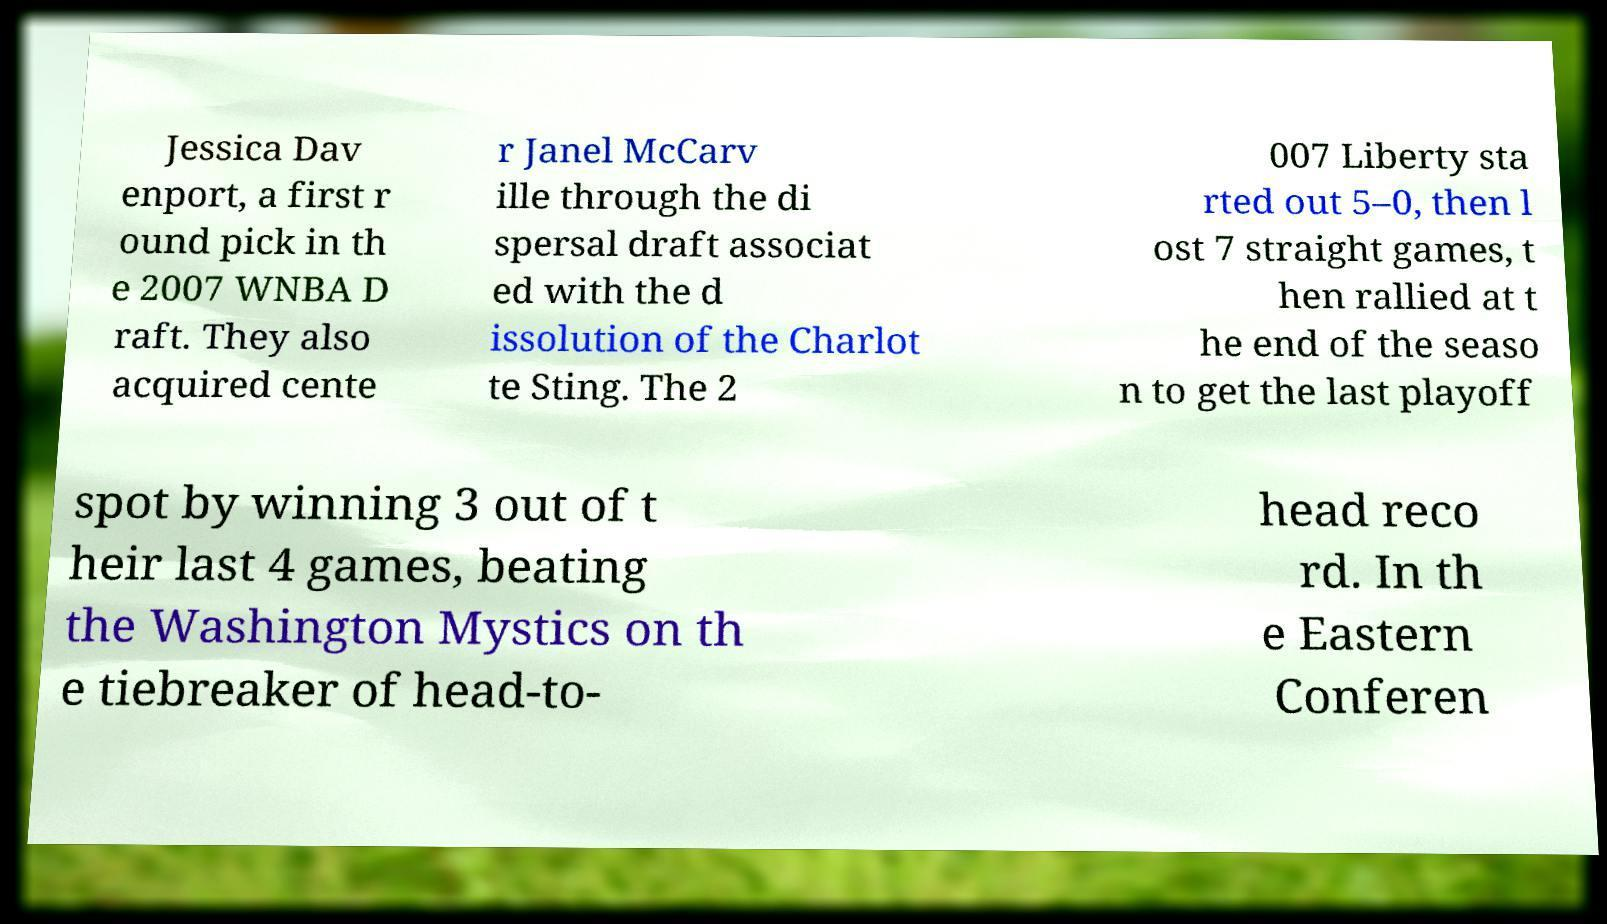Can you accurately transcribe the text from the provided image for me? Jessica Dav enport, a first r ound pick in th e 2007 WNBA D raft. They also acquired cente r Janel McCarv ille through the di spersal draft associat ed with the d issolution of the Charlot te Sting. The 2 007 Liberty sta rted out 5–0, then l ost 7 straight games, t hen rallied at t he end of the seaso n to get the last playoff spot by winning 3 out of t heir last 4 games, beating the Washington Mystics on th e tiebreaker of head-to- head reco rd. In th e Eastern Conferen 